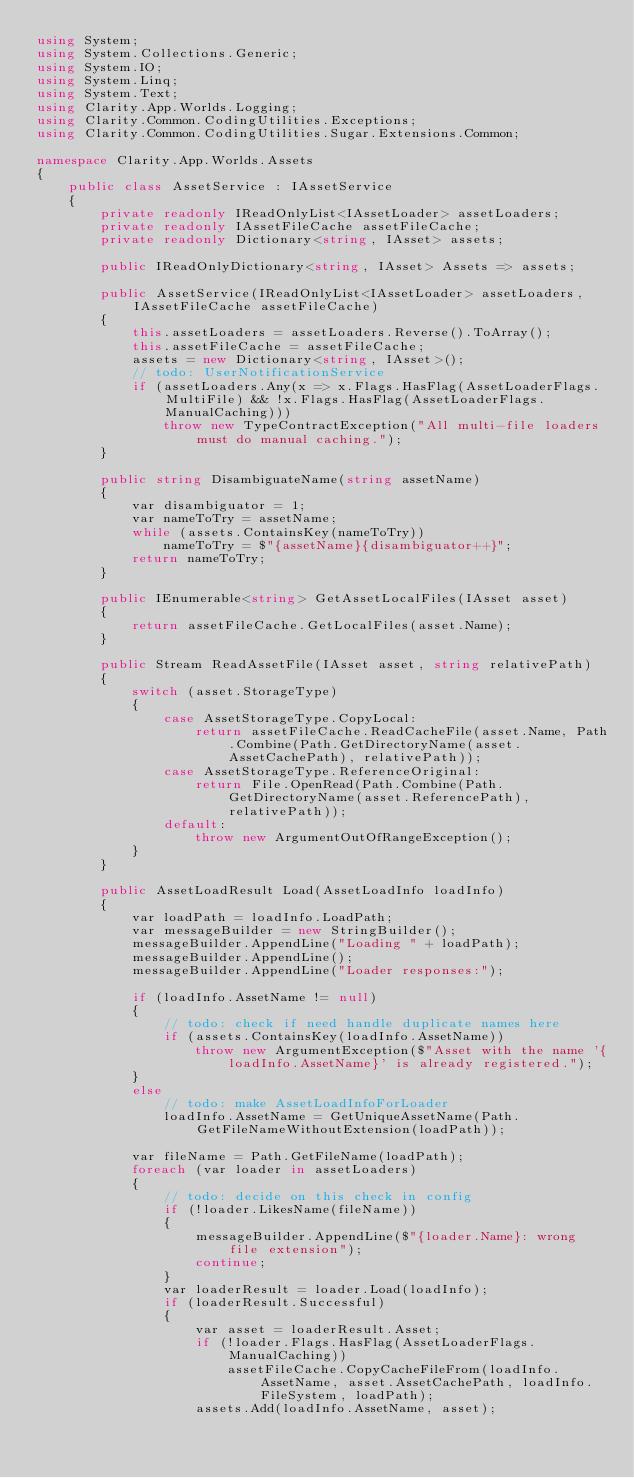<code> <loc_0><loc_0><loc_500><loc_500><_C#_>using System;
using System.Collections.Generic;
using System.IO;
using System.Linq;
using System.Text;
using Clarity.App.Worlds.Logging;
using Clarity.Common.CodingUtilities.Exceptions;
using Clarity.Common.CodingUtilities.Sugar.Extensions.Common;

namespace Clarity.App.Worlds.Assets
{
    public class AssetService : IAssetService
    {
        private readonly IReadOnlyList<IAssetLoader> assetLoaders;
        private readonly IAssetFileCache assetFileCache;
        private readonly Dictionary<string, IAsset> assets;

        public IReadOnlyDictionary<string, IAsset> Assets => assets;

        public AssetService(IReadOnlyList<IAssetLoader> assetLoaders, IAssetFileCache assetFileCache)
        {
            this.assetLoaders = assetLoaders.Reverse().ToArray();
            this.assetFileCache = assetFileCache;
            assets = new Dictionary<string, IAsset>();
            // todo: UserNotificationService
            if (assetLoaders.Any(x => x.Flags.HasFlag(AssetLoaderFlags.MultiFile) && !x.Flags.HasFlag(AssetLoaderFlags.ManualCaching)))
                throw new TypeContractException("All multi-file loaders must do manual caching.");
        }

        public string DisambiguateName(string assetName)
        {
            var disambiguator = 1;
            var nameToTry = assetName;
            while (assets.ContainsKey(nameToTry))
                nameToTry = $"{assetName}{disambiguator++}";
            return nameToTry;
        }

        public IEnumerable<string> GetAssetLocalFiles(IAsset asset)
        {
            return assetFileCache.GetLocalFiles(asset.Name);
        }

        public Stream ReadAssetFile(IAsset asset, string relativePath)
        {
            switch (asset.StorageType)
            {
                case AssetStorageType.CopyLocal:
                    return assetFileCache.ReadCacheFile(asset.Name, Path.Combine(Path.GetDirectoryName(asset.AssetCachePath), relativePath));
                case AssetStorageType.ReferenceOriginal:
                    return File.OpenRead(Path.Combine(Path.GetDirectoryName(asset.ReferencePath), relativePath));
                default:
                    throw new ArgumentOutOfRangeException();
            }
        }

        public AssetLoadResult Load(AssetLoadInfo loadInfo)
        {
            var loadPath = loadInfo.LoadPath;
            var messageBuilder = new StringBuilder();
            messageBuilder.AppendLine("Loading " + loadPath);
            messageBuilder.AppendLine();
            messageBuilder.AppendLine("Loader responses:");

            if (loadInfo.AssetName != null)
            {
                // todo: check if need handle duplicate names here
                if (assets.ContainsKey(loadInfo.AssetName))
                    throw new ArgumentException($"Asset with the name '{loadInfo.AssetName}' is already registered.");
            }
            else
                // todo: make AssetLoadInfoForLoader
                loadInfo.AssetName = GetUniqueAssetName(Path.GetFileNameWithoutExtension(loadPath));

            var fileName = Path.GetFileName(loadPath);
            foreach (var loader in assetLoaders)
            {
                // todo: decide on this check in config
                if (!loader.LikesName(fileName))
                {
                    messageBuilder.AppendLine($"{loader.Name}: wrong file extension");
                    continue;
                }
                var loaderResult = loader.Load(loadInfo);
                if (loaderResult.Successful)
                {
                    var asset = loaderResult.Asset;
                    if (!loader.Flags.HasFlag(AssetLoaderFlags.ManualCaching))
                        assetFileCache.CopyCacheFileFrom(loadInfo.AssetName, asset.AssetCachePath, loadInfo.FileSystem, loadPath);
                    assets.Add(loadInfo.AssetName, asset);</code> 